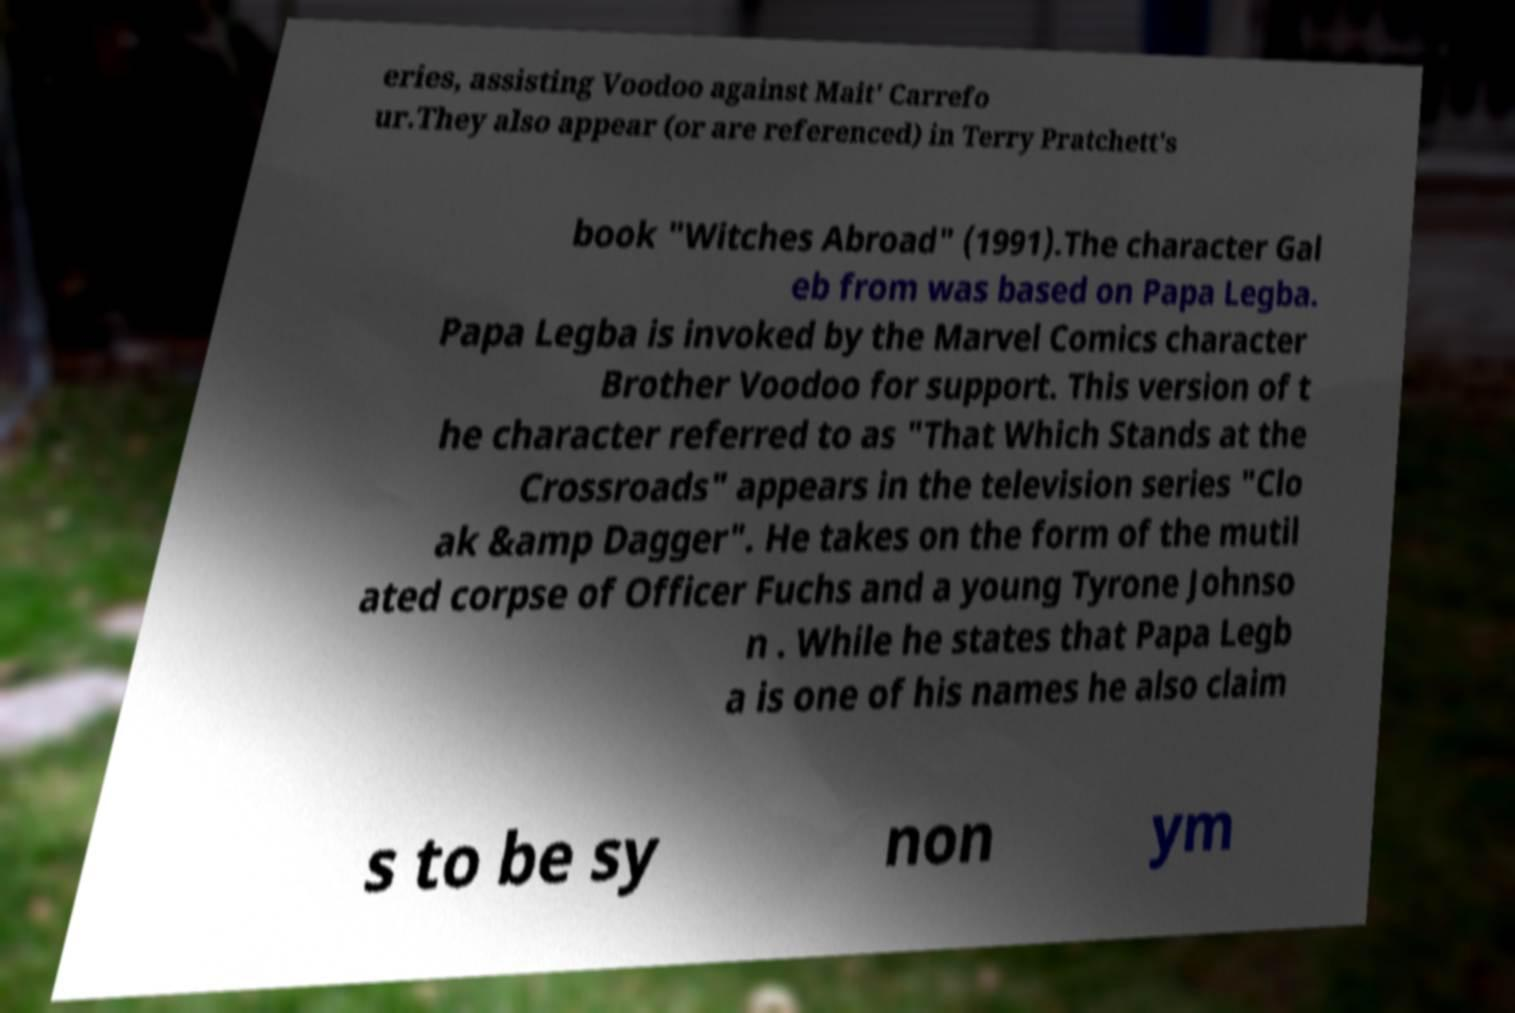What messages or text are displayed in this image? I need them in a readable, typed format. eries, assisting Voodoo against Mait' Carrefo ur.They also appear (or are referenced) in Terry Pratchett's book "Witches Abroad" (1991).The character Gal eb from was based on Papa Legba. Papa Legba is invoked by the Marvel Comics character Brother Voodoo for support. This version of t he character referred to as "That Which Stands at the Crossroads" appears in the television series "Clo ak &amp Dagger". He takes on the form of the mutil ated corpse of Officer Fuchs and a young Tyrone Johnso n . While he states that Papa Legb a is one of his names he also claim s to be sy non ym 